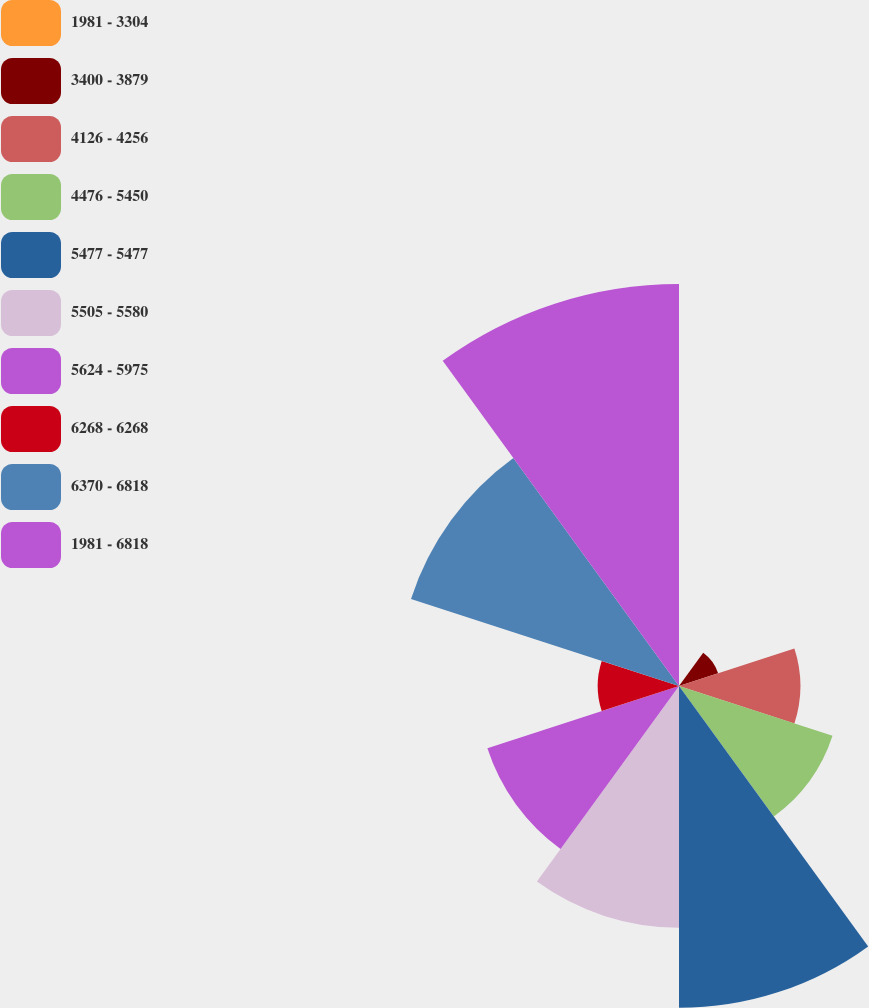Convert chart to OTSL. <chart><loc_0><loc_0><loc_500><loc_500><pie_chart><fcel>1981 - 3304<fcel>3400 - 3879<fcel>4126 - 4256<fcel>4476 - 5450<fcel>5477 - 5477<fcel>5505 - 5580<fcel>5624 - 5975<fcel>6268 - 6268<fcel>6370 - 6818<fcel>1981 - 6818<nl><fcel>0.06%<fcel>2.22%<fcel>6.54%<fcel>8.7%<fcel>17.35%<fcel>13.03%<fcel>10.86%<fcel>4.38%<fcel>15.19%<fcel>21.67%<nl></chart> 